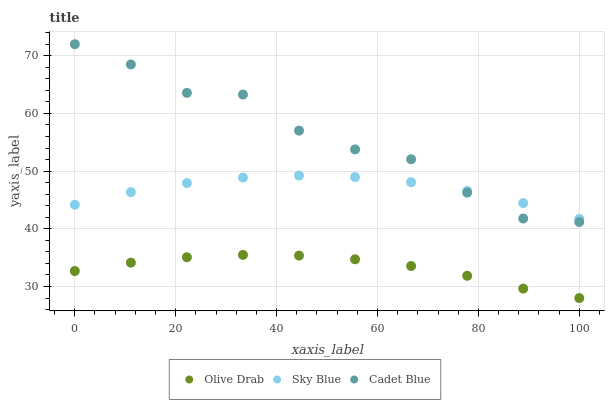Does Olive Drab have the minimum area under the curve?
Answer yes or no. Yes. Does Cadet Blue have the maximum area under the curve?
Answer yes or no. Yes. Does Cadet Blue have the minimum area under the curve?
Answer yes or no. No. Does Olive Drab have the maximum area under the curve?
Answer yes or no. No. Is Olive Drab the smoothest?
Answer yes or no. Yes. Is Cadet Blue the roughest?
Answer yes or no. Yes. Is Cadet Blue the smoothest?
Answer yes or no. No. Is Olive Drab the roughest?
Answer yes or no. No. Does Olive Drab have the lowest value?
Answer yes or no. Yes. Does Cadet Blue have the lowest value?
Answer yes or no. No. Does Cadet Blue have the highest value?
Answer yes or no. Yes. Does Olive Drab have the highest value?
Answer yes or no. No. Is Olive Drab less than Sky Blue?
Answer yes or no. Yes. Is Cadet Blue greater than Olive Drab?
Answer yes or no. Yes. Does Cadet Blue intersect Sky Blue?
Answer yes or no. Yes. Is Cadet Blue less than Sky Blue?
Answer yes or no. No. Is Cadet Blue greater than Sky Blue?
Answer yes or no. No. Does Olive Drab intersect Sky Blue?
Answer yes or no. No. 